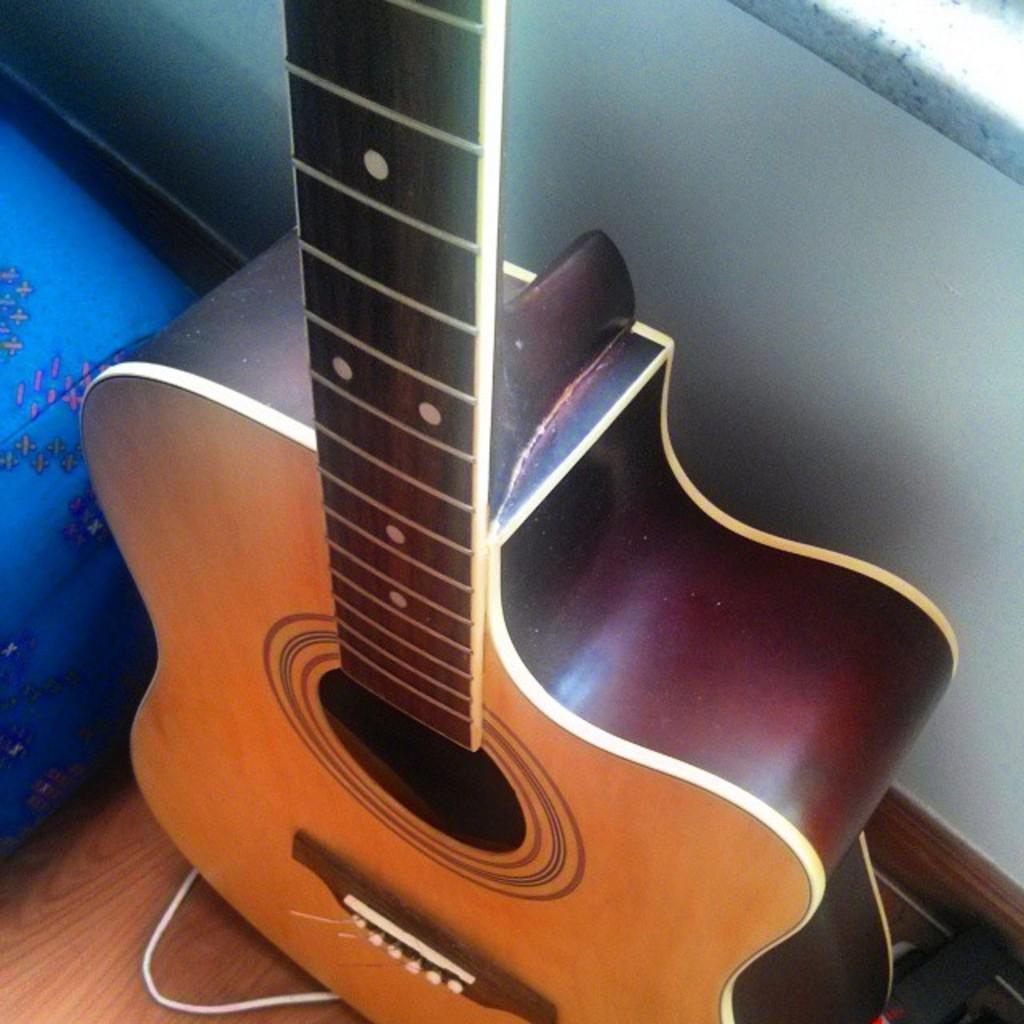Please provide a concise description of this image. It's a guitar and a wall. 